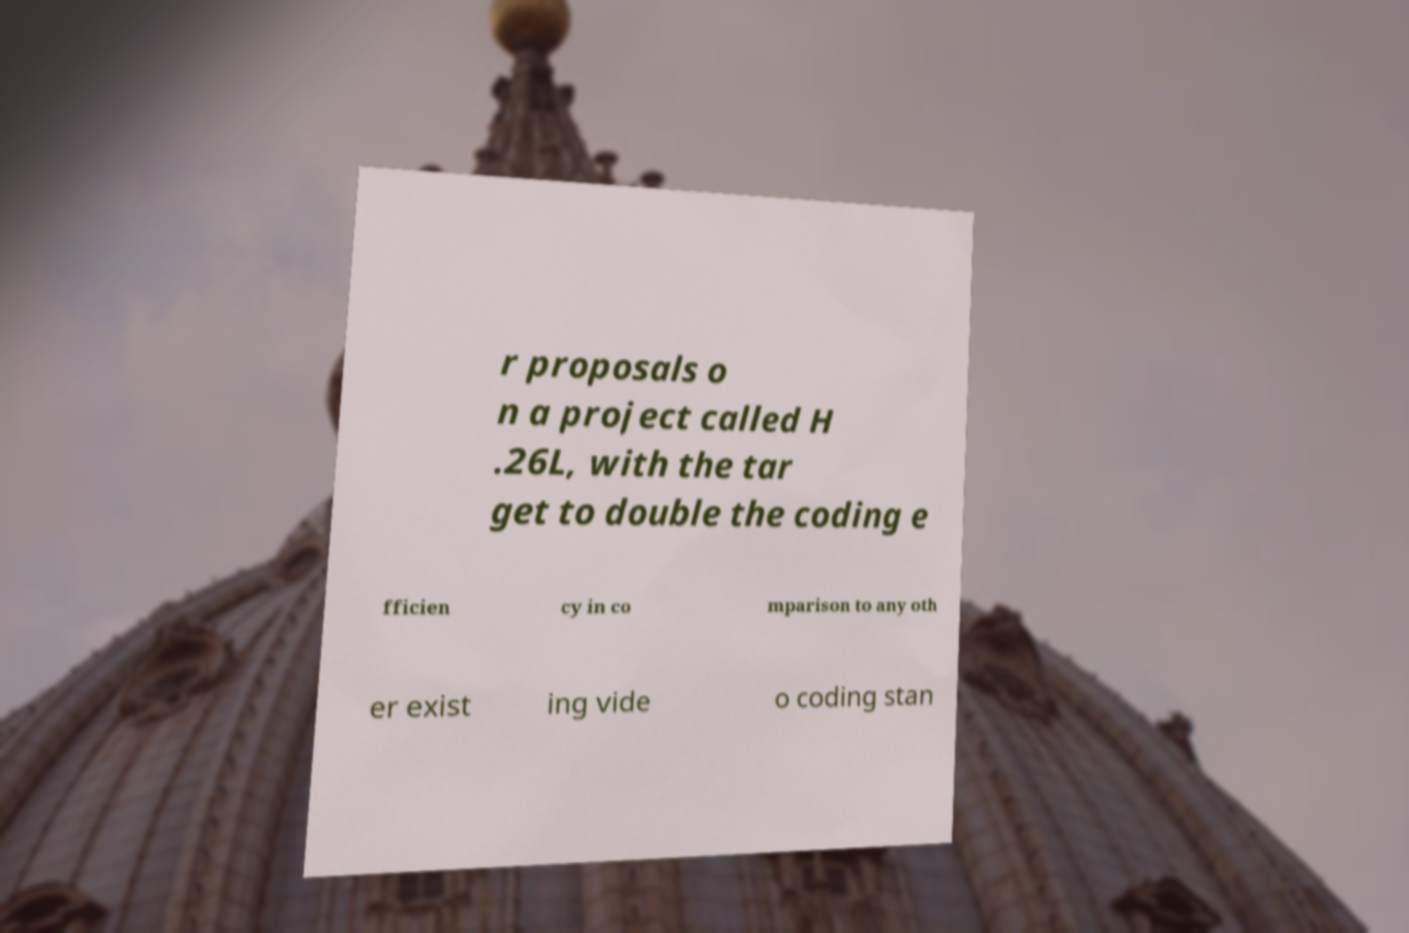Please identify and transcribe the text found in this image. r proposals o n a project called H .26L, with the tar get to double the coding e fficien cy in co mparison to any oth er exist ing vide o coding stan 